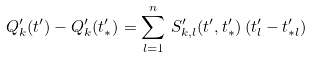Convert formula to latex. <formula><loc_0><loc_0><loc_500><loc_500>Q _ { k } ^ { \prime } ( t ^ { \prime } ) - Q _ { k } ^ { \prime } ( t _ { * } ^ { \prime } ) = \sum _ { l = 1 } ^ { n } \, S _ { k , l } ^ { \prime } ( t ^ { \prime } , t _ { * } ^ { \prime } ) \, ( t _ { l } ^ { \prime } - t _ { * l } ^ { \prime } )</formula> 